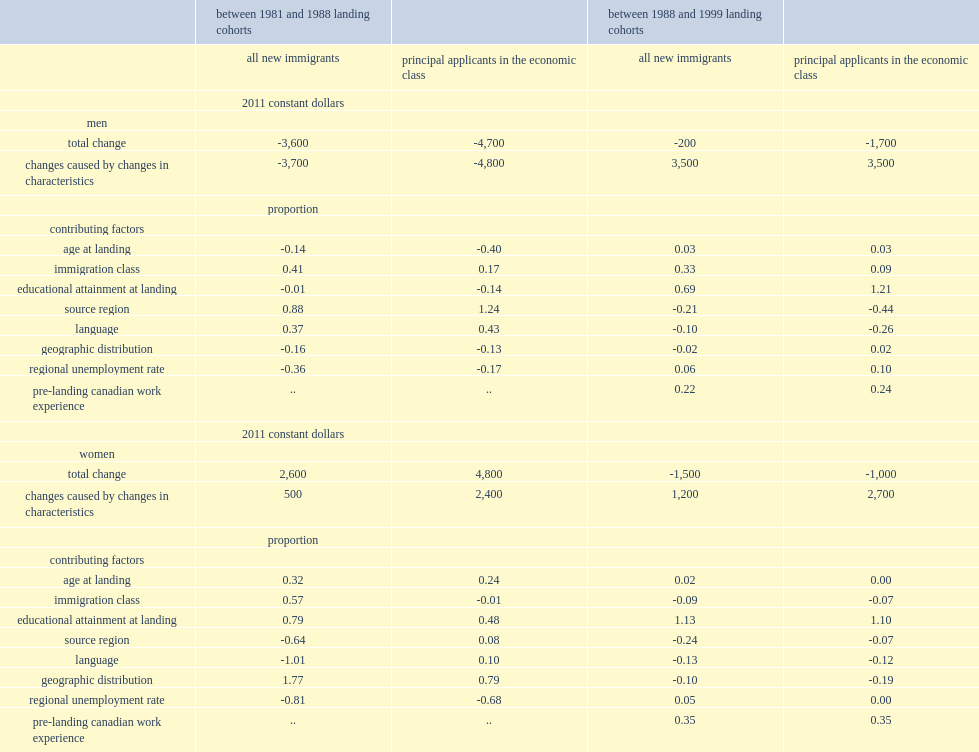What percentage of the accounted-for rise in earnings of men between 1988 and 1999 is accounted by rising educational attainment at landing of immigrants? 0.69. What is the most significant factor putting upward pressure on entry earnings for immigrant men? Educational attainment at landing. Changing characteristics had less effect on the entry earnings of which group during the 1990s, immigrant women or immigrant men? Women. How much average entry earnings was improved by changing characteristics for women? 1200.0. How much average entry earnings was improved by changing characteristics for men? 3500.0. How much did entry earnings among men decline between the 1981 and 1988 landing cohorts? -3600.0. How much did entry earnings rise among new immigrant women between the 1981 and 1988 landing cohorts? 2600.0. How much of the total increase in immigrant women's entry earnings between the 1981 and 1988 landing cohorts was caused by the included explanatory variables? 500.0. How much did immigrant women's entry earnings between the 1981 and 1988 landing cohorts increase? 2600.0. 